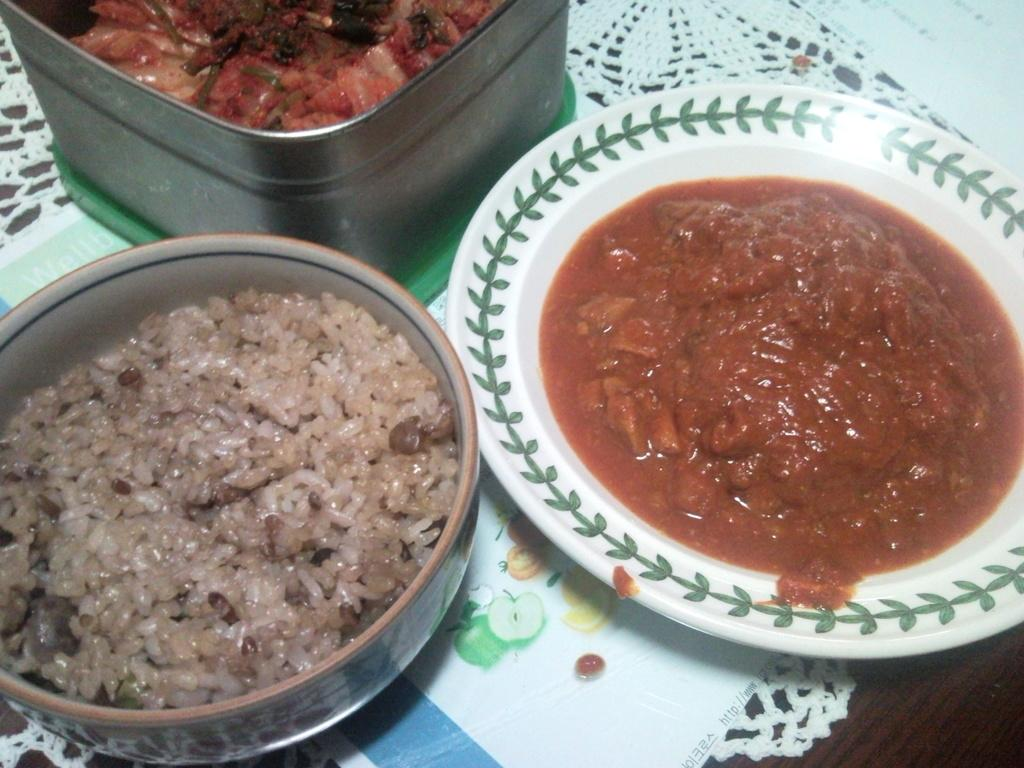What piece of furniture is present in the image? There is a table in the image. How many bowls are on the table? There are two bowls on the table. What else is on the table besides the bowls? There is one plate on the table. What can be found on the plate? There are food items on the plate. What type of pollution can be seen in the image? There is no pollution present in the image; it features a table with bowls and a plate. What is the texture of the brick in the image? There is no brick present in the image. 